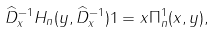Convert formula to latex. <formula><loc_0><loc_0><loc_500><loc_500>\widehat { D } _ { x } ^ { - 1 } H _ { n } ( y , \widehat { D } _ { x } ^ { - 1 } ) 1 = x \Pi _ { n } ^ { 1 } ( x , y ) ,</formula> 